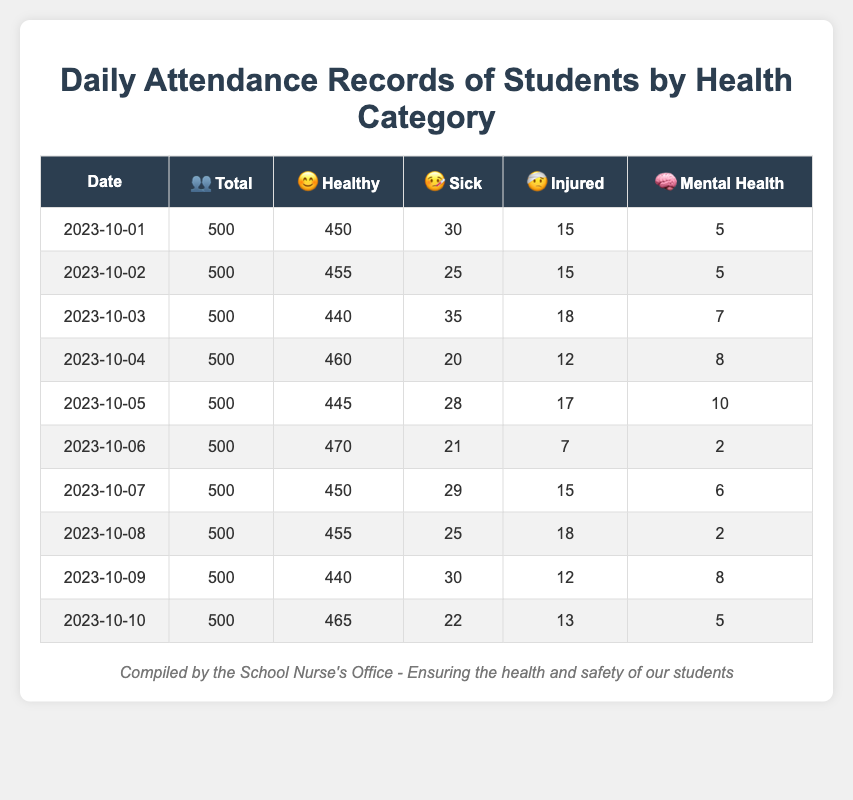What was the total number of sick students on October 3rd? The table shows that on October 3rd, the number of sick students was explicitly listed as 35.
Answer: 35 What was the average number of healthy students over the ten days? The average can be calculated by summing the healthy students for each day (450 + 455 + 440 + 460 + 445 + 470 + 450 + 455 + 440 + 465 = 4,465) and dividing by the total number of days (10). So, 4,465 / 10 = 446.5.
Answer: 446.5 On which day were the most injured students recorded? By checking the injured column for each day, October 3rd had the highest count of injured students, which was 18.
Answer: October 3rd Is the number of mental health cases ever greater than 10 during the recorded dates? Scanning the mental health column reveals that the highest count was 10 on October 5th, so no day had more than 10 cases.
Answer: No What was the total attendance of healthy, sick, and injured students on October 2nd? Adding the healthy (455), sick (25), and injured (15) students on that date gives 455 + 25 + 15 = 495.
Answer: 495 How many total students were healthy on the days where sick students exceeded 30? Looking at the days where sick students exceeded 30, they are October 3rd (440), October 5th (445), October 9th (440). Adding these gives 440 + 445 + 440 = 1,325.
Answer: 1,325 What percent of total students were mentally healthy on October 6th? The table shows 2 mental health cases out of 500 total students on October 6th. The percentage is calculated as (2 / 500) * 100 = 0.4%.
Answer: 0.4% How did the total number of sick students change from October 1st to October 10th? Comparing the sick students on October 1st (30) to October 10th (22), the change is calculated as 30 - 22 = 8. This indicates a decrease.
Answer: Decreased by 8 What was the highest number of total students recorded throughout the ten days? The total number of students remained constant at 500 each day according to the table.
Answer: 500 On which date were there fewer than 25 sick students? Looking at the sick students column from the table, the days October 2nd (25), October 4th (20), and October 8th (25) list fewer than 25 sick students only on October 4th.
Answer: October 4th 